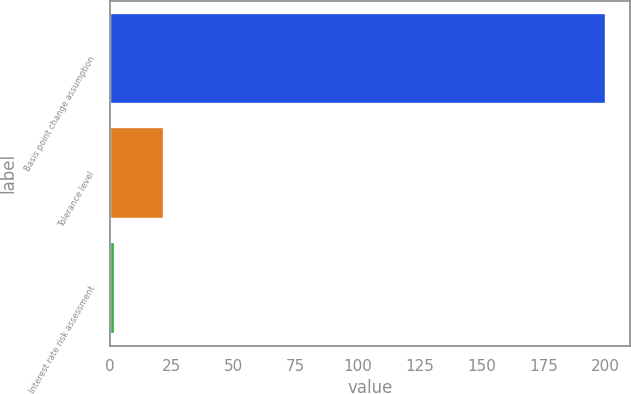<chart> <loc_0><loc_0><loc_500><loc_500><bar_chart><fcel>Basis point change assumption<fcel>Tolerance level<fcel>Interest rate risk assessment<nl><fcel>200<fcel>22<fcel>2.22<nl></chart> 